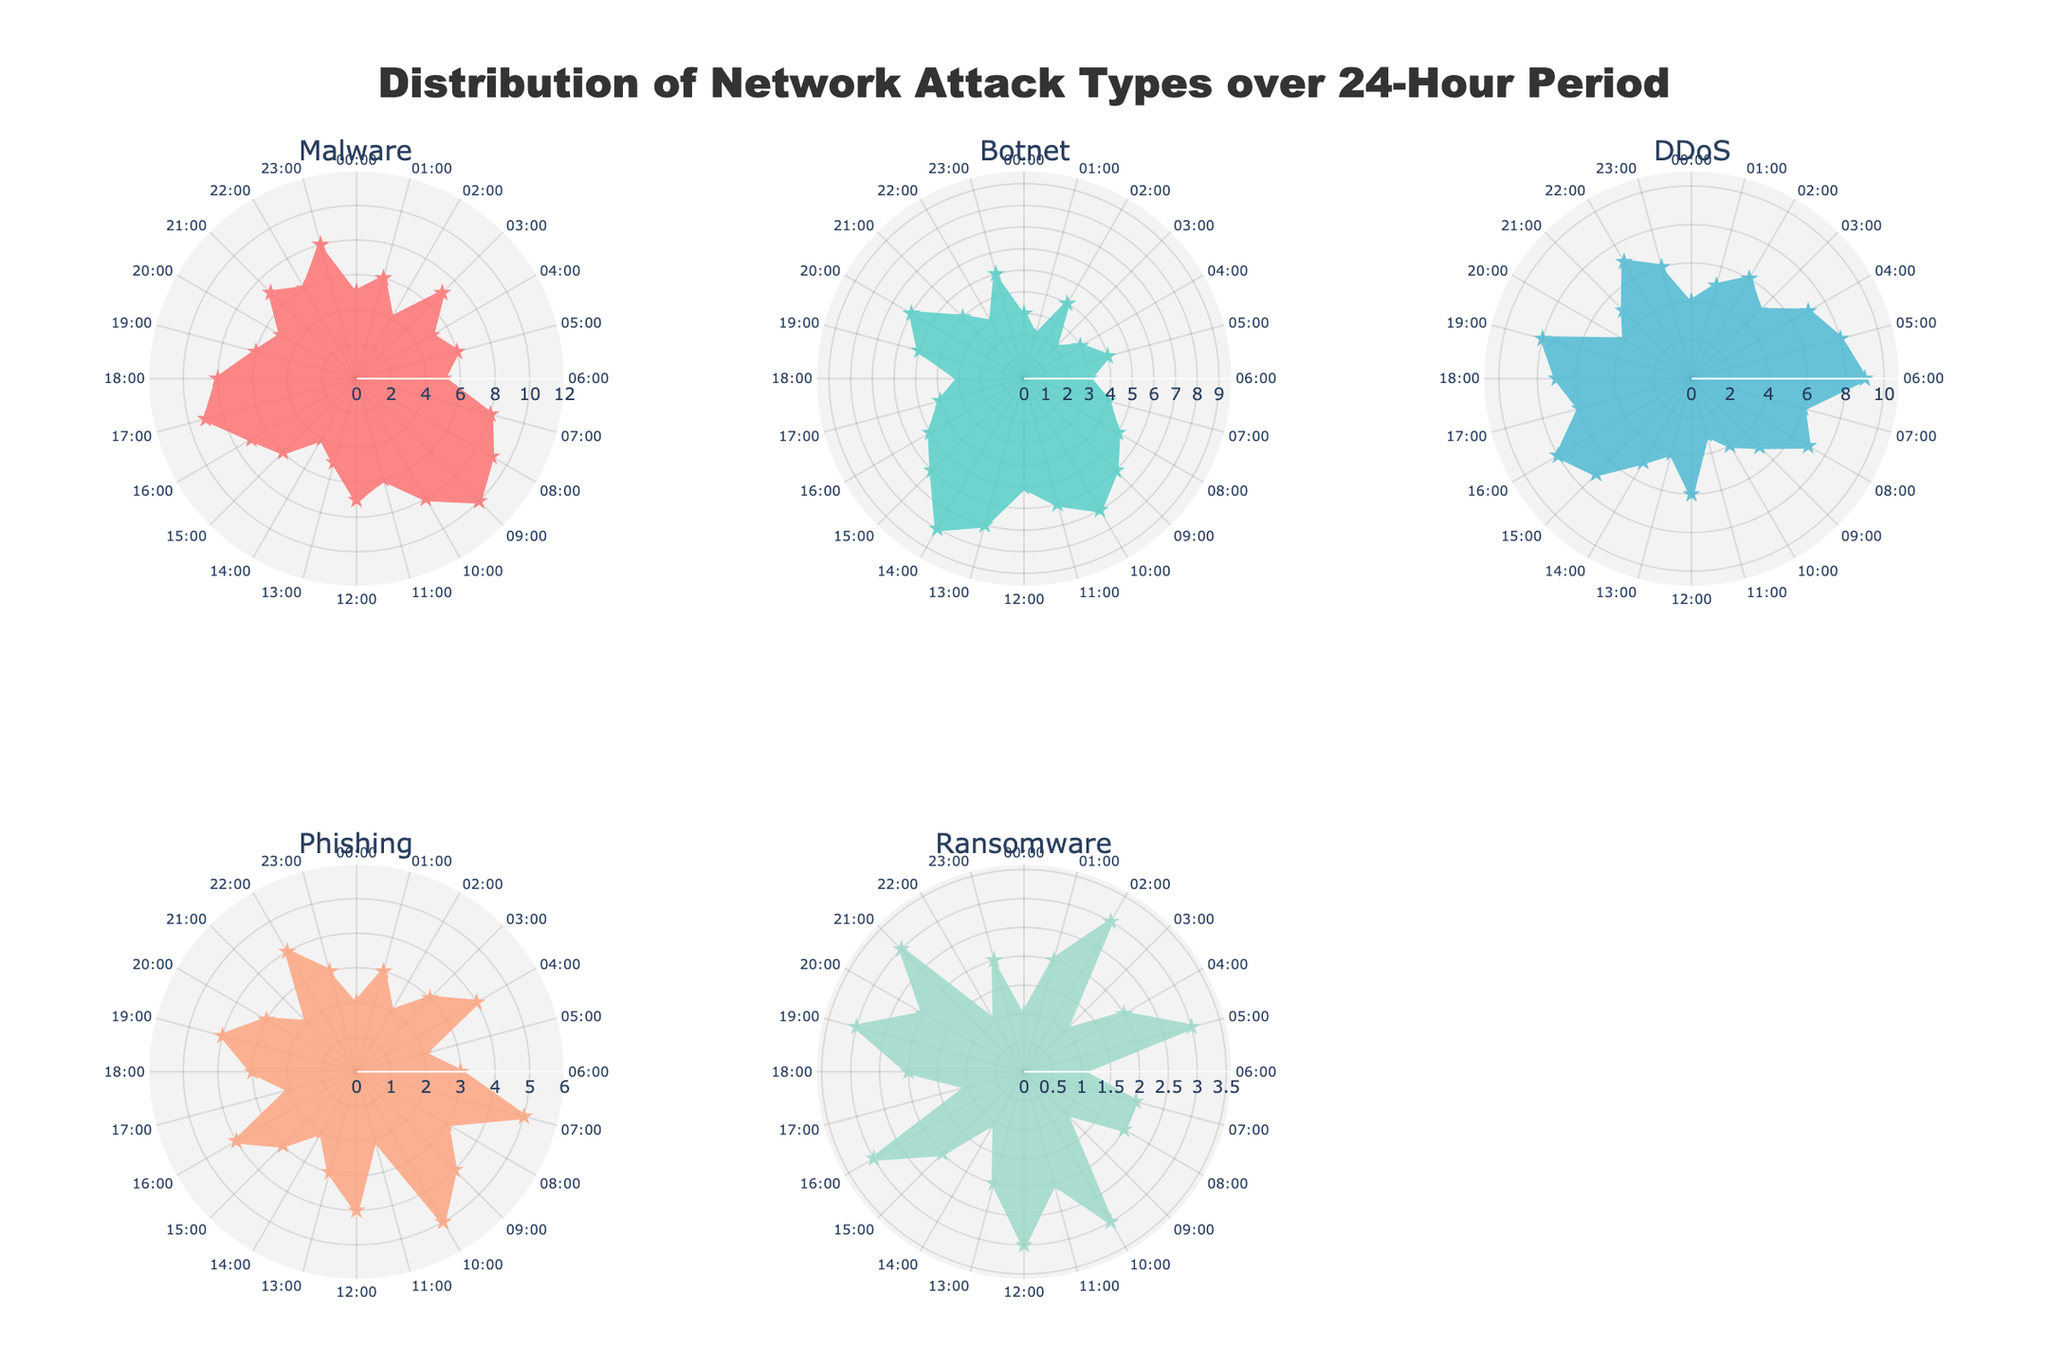what is the title of the figure? The title is typically located at the top of the figure and in this case, it reads "Distribution of Network Attack Types over 24-Hour Period".
Answer: Distribution of Network Attack Types over 24-Hour Period Which attack type has the highest count at 09:00? To determine this, look at the data points for each attack type on the polar chart corresponding to 09:00. According to the data, Malware has the highest count at this time.
Answer: Malware At what times does Ransomware have a count of 3? By examining the data points for Ransomware across the 24-hour period, we see that Ransomware has a count of 3 at 02:00, 05:00, 10:00, 12:00, 16:00, 19:00, and 21:00.
Answer: 02:00, 05:00, 10:00, 12:00, 16:00, 19:00, 21:00 What is the range of counts for DDoS attacks? The range of counts is determined by finding the difference between the maximum and minimum counts of DDoS, which are 9 and 3, respectively. So, the range is 9 - 3 = 6.
Answer: 6 Which attack type has the most noticeable peak in the early morning hours (midnight to 6 AM)? Observing the early morning hours subplot, DDoS has the most noticeable and consistent peak among the attack types.
Answer: DDoS Compare the count of Botnet attacks at 10:00 and 14:00. Which one is higher? Looking at the respective data points, the count of Botnet attacks at 14:00 is 8, which is higher than the count at 10:00, which is 7.
Answer: 14:00 Which attack type shows the least variation over the 24-hour period? By examining the polar charts, Phishing has the least variation in counts, fluctuating only slightly over the period.
Answer: Phishing During which hour is the count of Malware and DDoS equal? Checking the data, Malware and DDoS counts are equal at 03:00, both having a count of 7.
Answer: 03:00 